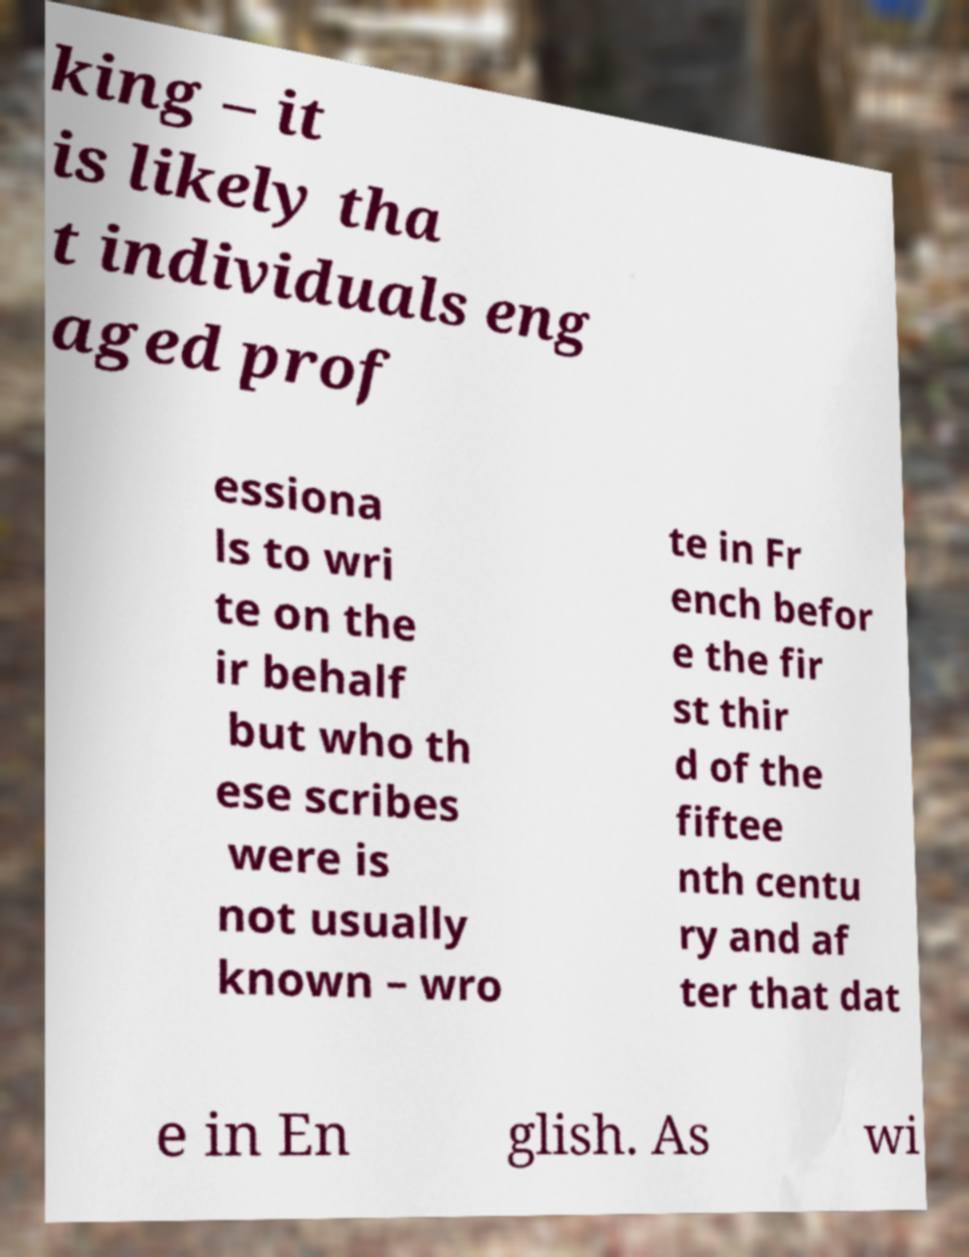There's text embedded in this image that I need extracted. Can you transcribe it verbatim? king – it is likely tha t individuals eng aged prof essiona ls to wri te on the ir behalf but who th ese scribes were is not usually known – wro te in Fr ench befor e the fir st thir d of the fiftee nth centu ry and af ter that dat e in En glish. As wi 